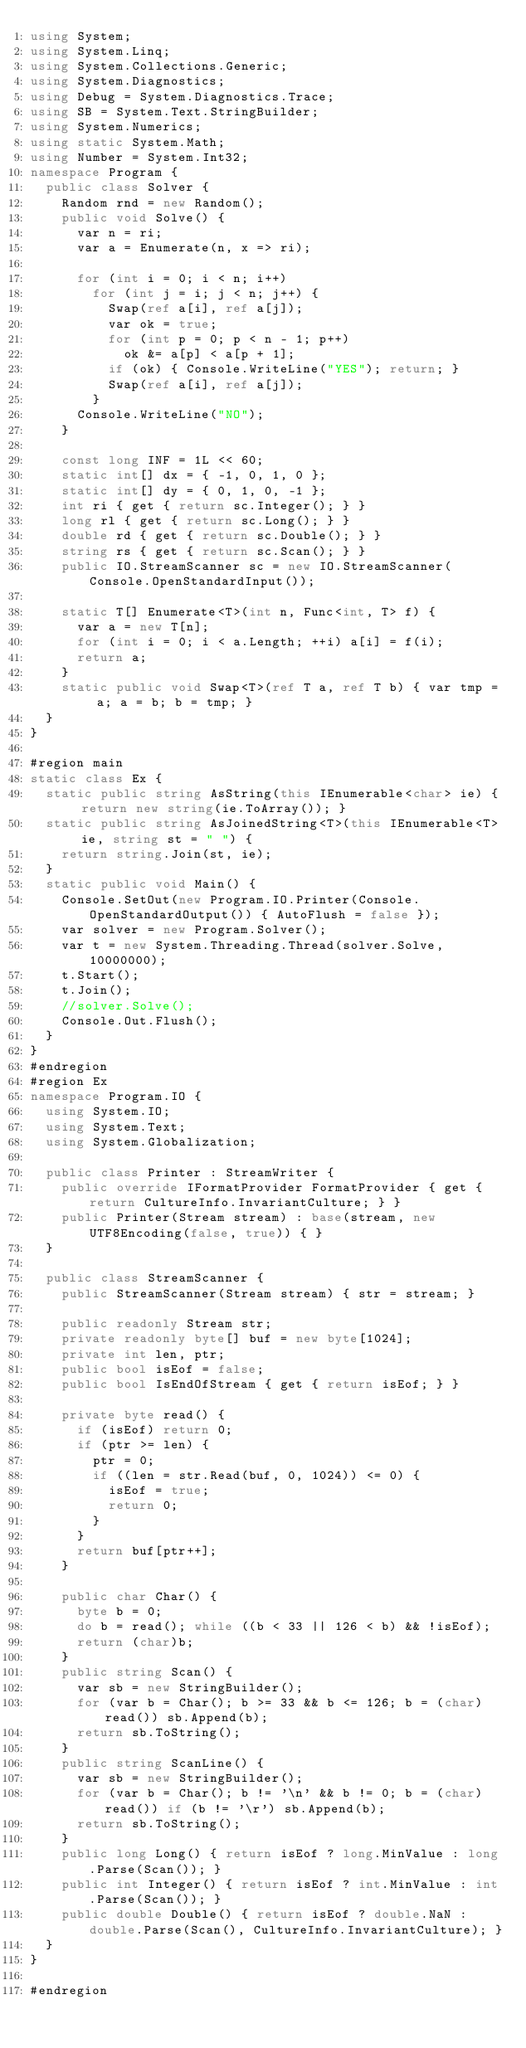Convert code to text. <code><loc_0><loc_0><loc_500><loc_500><_C#_>using System;
using System.Linq;
using System.Collections.Generic;
using System.Diagnostics;
using Debug = System.Diagnostics.Trace;
using SB = System.Text.StringBuilder;
using System.Numerics;
using static System.Math;
using Number = System.Int32;
namespace Program {
	public class Solver {
		Random rnd = new Random();
		public void Solve() {
			var n = ri;
			var a = Enumerate(n, x => ri);

			for (int i = 0; i < n; i++)
				for (int j = i; j < n; j++) {
					Swap(ref a[i], ref a[j]);
					var ok = true;
					for (int p = 0; p < n - 1; p++)
						ok &= a[p] < a[p + 1];
					if (ok) { Console.WriteLine("YES"); return; }
					Swap(ref a[i], ref a[j]);
				}
			Console.WriteLine("NO");
		}

		const long INF = 1L << 60;
		static int[] dx = { -1, 0, 1, 0 };
		static int[] dy = { 0, 1, 0, -1 };
		int ri { get { return sc.Integer(); } }
		long rl { get { return sc.Long(); } }
		double rd { get { return sc.Double(); } }
		string rs { get { return sc.Scan(); } }
		public IO.StreamScanner sc = new IO.StreamScanner(Console.OpenStandardInput());

		static T[] Enumerate<T>(int n, Func<int, T> f) {
			var a = new T[n];
			for (int i = 0; i < a.Length; ++i) a[i] = f(i);
			return a;
		}
		static public void Swap<T>(ref T a, ref T b) { var tmp = a; a = b; b = tmp; }
	}
}

#region main
static class Ex {
	static public string AsString(this IEnumerable<char> ie) { return new string(ie.ToArray()); }
	static public string AsJoinedString<T>(this IEnumerable<T> ie, string st = " ") {
		return string.Join(st, ie);
	}
	static public void Main() {
		Console.SetOut(new Program.IO.Printer(Console.OpenStandardOutput()) { AutoFlush = false });
		var solver = new Program.Solver();
		var t = new System.Threading.Thread(solver.Solve, 10000000);
		t.Start();
		t.Join();
		//solver.Solve();
		Console.Out.Flush();
	}
}
#endregion
#region Ex
namespace Program.IO {
	using System.IO;
	using System.Text;
	using System.Globalization;

	public class Printer : StreamWriter {
		public override IFormatProvider FormatProvider { get { return CultureInfo.InvariantCulture; } }
		public Printer(Stream stream) : base(stream, new UTF8Encoding(false, true)) { }
	}

	public class StreamScanner {
		public StreamScanner(Stream stream) { str = stream; }

		public readonly Stream str;
		private readonly byte[] buf = new byte[1024];
		private int len, ptr;
		public bool isEof = false;
		public bool IsEndOfStream { get { return isEof; } }

		private byte read() {
			if (isEof) return 0;
			if (ptr >= len) {
				ptr = 0;
				if ((len = str.Read(buf, 0, 1024)) <= 0) {
					isEof = true;
					return 0;
				}
			}
			return buf[ptr++];
		}

		public char Char() {
			byte b = 0;
			do b = read(); while ((b < 33 || 126 < b) && !isEof);
			return (char)b;
		}
		public string Scan() {
			var sb = new StringBuilder();
			for (var b = Char(); b >= 33 && b <= 126; b = (char)read()) sb.Append(b);
			return sb.ToString();
		}
		public string ScanLine() {
			var sb = new StringBuilder();
			for (var b = Char(); b != '\n' && b != 0; b = (char)read()) if (b != '\r') sb.Append(b);
			return sb.ToString();
		}
		public long Long() { return isEof ? long.MinValue : long.Parse(Scan()); }
		public int Integer() { return isEof ? int.MinValue : int.Parse(Scan()); }
		public double Double() { return isEof ? double.NaN : double.Parse(Scan(), CultureInfo.InvariantCulture); }
	}
}

#endregion
</code> 